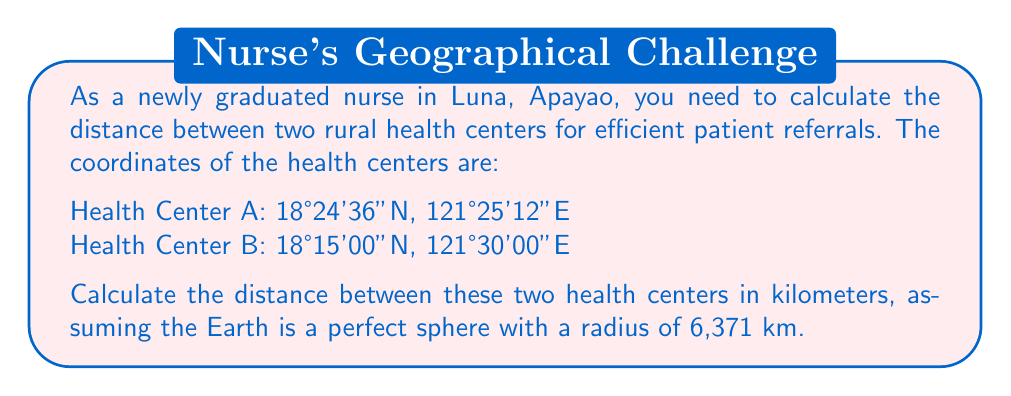What is the answer to this math problem? To calculate the distance between two points on Earth using their latitude and longitude coordinates, we'll use the Haversine formula:

1) First, convert the coordinates from degrees, minutes, and seconds to decimal degrees:
   Health Center A: 18°24'36"N = 18.41°N, 121°25'12"E = 121.42°E
   Health Center B: 18°15'00"N = 18.25°N, 121°30'00"E = 121.50°E

2) Convert latitude and longitude from degrees to radians:
   $$\text{lat}_1 = 18.41° \times \frac{\pi}{180} = 0.3213 \text{ rad}$$
   $$\text{lon}_1 = 121.42° \times \frac{\pi}{180} = 2.1189 \text{ rad}$$
   $$\text{lat}_2 = 18.25° \times \frac{\pi}{180} = 0.3185 \text{ rad}$$
   $$\text{lon}_2 = 121.50° \times \frac{\pi}{180} = 2.1203 \text{ rad}$$

3) Calculate the differences:
   $$\Delta\text{lat} = \text{lat}_2 - \text{lat}_1 = 0.3185 - 0.3213 = -0.0028 \text{ rad}$$
   $$\Delta\text{lon} = \text{lon}_2 - \text{lon}_1 = 2.1203 - 2.1189 = 0.0014 \text{ rad}$$

4) Apply the Haversine formula:
   $$a = \sin^2(\frac{\Delta\text{lat}}{2}) + \cos(\text{lat}_1) \cos(\text{lat}_2) \sin^2(\frac{\Delta\text{lon}}{2})$$
   $$a = \sin^2(-0.0014) + \cos(0.3213) \cos(0.3185) \sin^2(0.0007)$$
   $$a = 0.00000196 + 0.94846 \times 0.94872 \times 0.00000049$$
   $$a = 0.00000196 + 0.00000044 = 0.0000024$$

5) Calculate the central angle:
   $$c = 2 \times \arctan2(\sqrt{a}, \sqrt{1-a})$$
   $$c = 2 \times \arctan2(\sqrt{0.0000024}, \sqrt{1-0.0000024})$$
   $$c = 2 \times 0.00155 = 0.0031 \text{ rad}$$

6) Calculate the distance:
   $$d = R \times c$$
   Where $R$ is the Earth's radius (6,371 km)
   $$d = 6371 \times 0.0031 = 19.75 \text{ km}$$

Therefore, the distance between the two rural health centers is approximately 19.75 km.
Answer: 19.75 km 